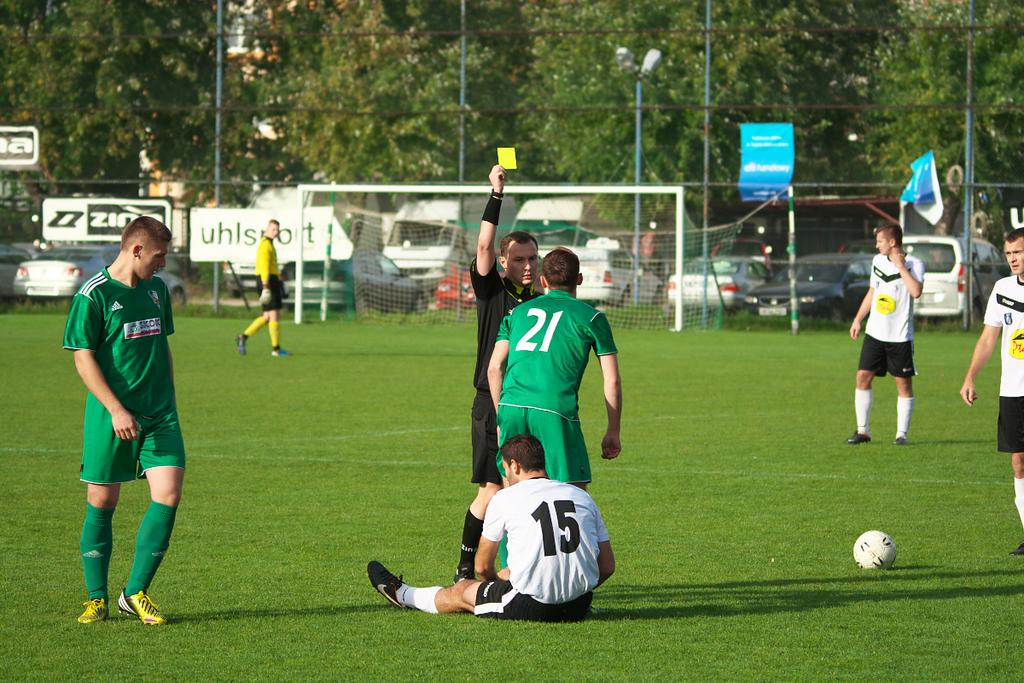<image>
Provide a brief description of the given image. One of the sponsors involved in the soccer match is Uhlsport. 